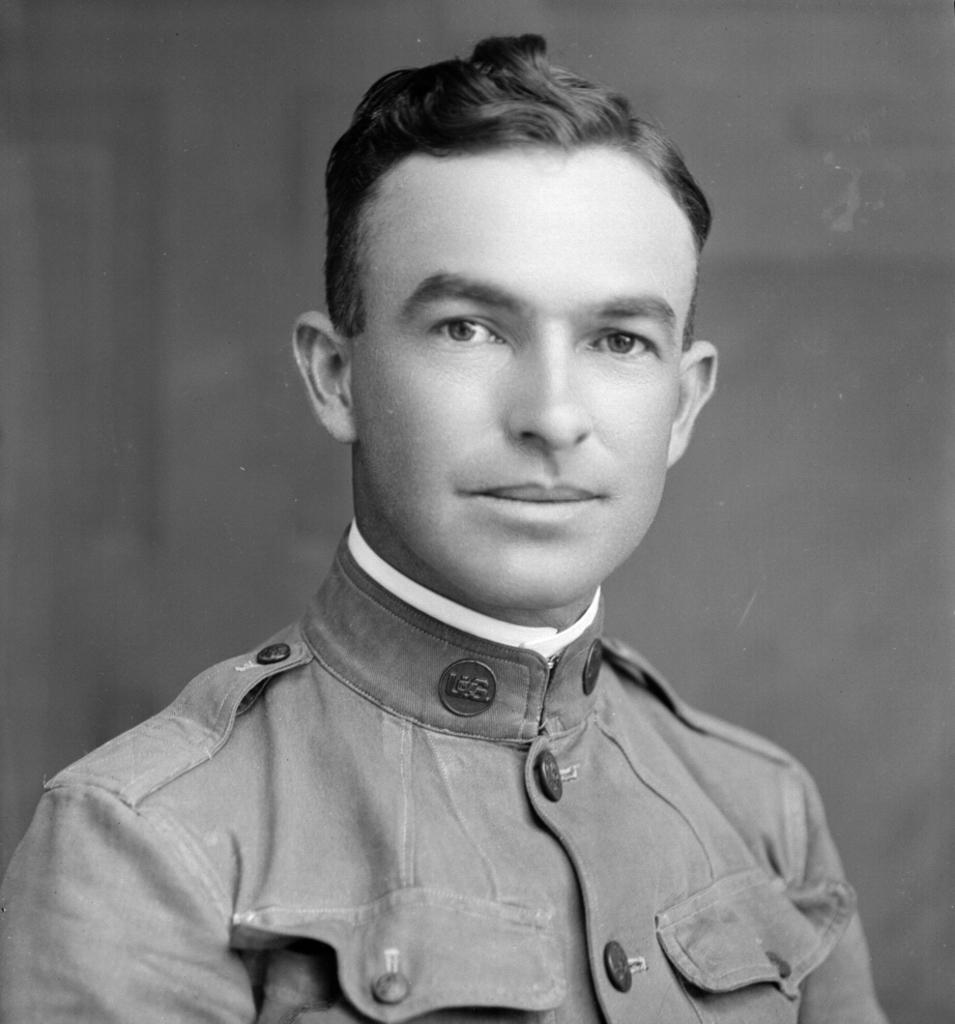Who is the main subject in the image? There is a man in the image. Where is the man located in the image? The man is in the middle of the image. What is the man wearing in the image? The man is wearing a shirt. What type of dinner is the man preparing in the image? There is no indication of a dinner or any cooking activity in the image; the man is simply standing in the middle of the image wearing a shirt. 